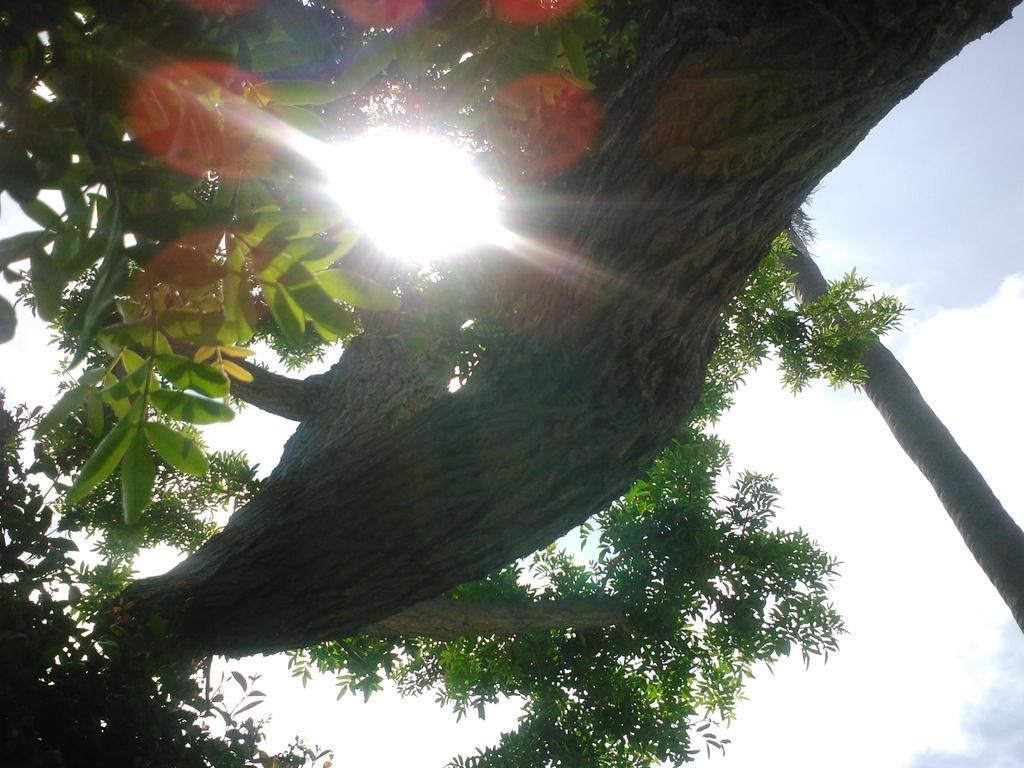What type of vegetation can be seen in the image? There are trees in the image. What is the color of the trees? The trees are green in color. What else is visible in the image besides the trees? The sky is visible in the image. What colors can be seen in the sky? The sky has blue and white colors. Can you describe the presence of light in the image? Sunlight is present in the image. How many lines can be seen on the bear in the image? There is no bear present in the image, so it is not possible to answer that question. 